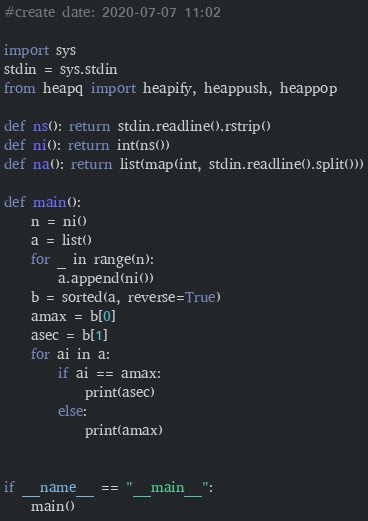<code> <loc_0><loc_0><loc_500><loc_500><_Python_>#create date: 2020-07-07 11:02

import sys
stdin = sys.stdin
from heapq import heapify, heappush, heappop

def ns(): return stdin.readline().rstrip()
def ni(): return int(ns())
def na(): return list(map(int, stdin.readline().split()))

def main():
    n = ni()
    a = list()
    for _ in range(n):
        a.append(ni())
    b = sorted(a, reverse=True)
    amax = b[0]
    asec = b[1]
    for ai in a:
        if ai == amax:
            print(asec)
        else:
            print(amax)


if __name__ == "__main__":
    main()</code> 